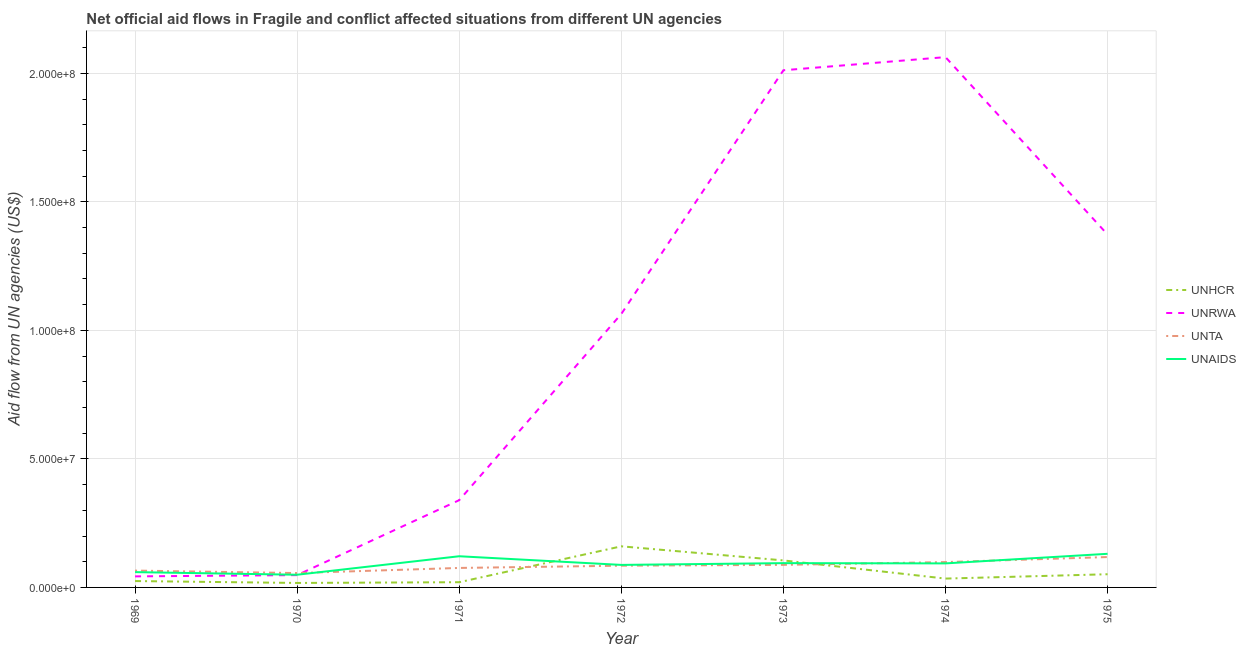Is the number of lines equal to the number of legend labels?
Ensure brevity in your answer.  Yes. What is the amount of aid given by unaids in 1973?
Provide a succinct answer. 9.45e+06. Across all years, what is the maximum amount of aid given by unta?
Ensure brevity in your answer.  1.18e+07. Across all years, what is the minimum amount of aid given by unaids?
Offer a terse response. 4.94e+06. In which year was the amount of aid given by unrwa maximum?
Offer a terse response. 1974. What is the total amount of aid given by unrwa in the graph?
Offer a very short reply. 6.94e+08. What is the difference between the amount of aid given by unta in 1969 and that in 1971?
Give a very brief answer. -1.03e+06. What is the difference between the amount of aid given by unhcr in 1972 and the amount of aid given by unrwa in 1970?
Offer a terse response. 1.12e+07. What is the average amount of aid given by unhcr per year?
Your response must be concise. 5.90e+06. In the year 1973, what is the difference between the amount of aid given by unrwa and amount of aid given by unta?
Your answer should be very brief. 1.92e+08. In how many years, is the amount of aid given by unrwa greater than 60000000 US$?
Offer a terse response. 4. What is the ratio of the amount of aid given by unta in 1970 to that in 1971?
Your response must be concise. 0.74. Is the amount of aid given by unrwa in 1969 less than that in 1970?
Give a very brief answer. Yes. Is the difference between the amount of aid given by unhcr in 1972 and 1975 greater than the difference between the amount of aid given by unta in 1972 and 1975?
Make the answer very short. Yes. What is the difference between the highest and the second highest amount of aid given by unaids?
Your answer should be very brief. 9.50e+05. What is the difference between the highest and the lowest amount of aid given by unhcr?
Your answer should be very brief. 1.42e+07. In how many years, is the amount of aid given by unta greater than the average amount of aid given by unta taken over all years?
Provide a succinct answer. 4. Is the sum of the amount of aid given by unrwa in 1971 and 1972 greater than the maximum amount of aid given by unaids across all years?
Offer a very short reply. Yes. Is the amount of aid given by unhcr strictly less than the amount of aid given by unrwa over the years?
Provide a short and direct response. Yes. How many lines are there?
Provide a short and direct response. 4. What is the difference between two consecutive major ticks on the Y-axis?
Your response must be concise. 5.00e+07. Does the graph contain any zero values?
Provide a short and direct response. No. What is the title of the graph?
Provide a succinct answer. Net official aid flows in Fragile and conflict affected situations from different UN agencies. What is the label or title of the X-axis?
Ensure brevity in your answer.  Year. What is the label or title of the Y-axis?
Provide a short and direct response. Aid flow from UN agencies (US$). What is the Aid flow from UN agencies (US$) in UNHCR in 1969?
Offer a terse response. 2.48e+06. What is the Aid flow from UN agencies (US$) of UNRWA in 1969?
Your response must be concise. 4.30e+06. What is the Aid flow from UN agencies (US$) in UNTA in 1969?
Provide a succinct answer. 6.55e+06. What is the Aid flow from UN agencies (US$) in UNAIDS in 1969?
Your answer should be very brief. 5.95e+06. What is the Aid flow from UN agencies (US$) of UNHCR in 1970?
Provide a short and direct response. 1.74e+06. What is the Aid flow from UN agencies (US$) in UNRWA in 1970?
Your answer should be very brief. 4.79e+06. What is the Aid flow from UN agencies (US$) of UNTA in 1970?
Offer a very short reply. 5.59e+06. What is the Aid flow from UN agencies (US$) of UNAIDS in 1970?
Offer a very short reply. 4.94e+06. What is the Aid flow from UN agencies (US$) in UNHCR in 1971?
Make the answer very short. 2.03e+06. What is the Aid flow from UN agencies (US$) in UNRWA in 1971?
Your answer should be very brief. 3.40e+07. What is the Aid flow from UN agencies (US$) of UNTA in 1971?
Give a very brief answer. 7.58e+06. What is the Aid flow from UN agencies (US$) of UNAIDS in 1971?
Keep it short and to the point. 1.21e+07. What is the Aid flow from UN agencies (US$) in UNHCR in 1972?
Provide a succinct answer. 1.60e+07. What is the Aid flow from UN agencies (US$) of UNRWA in 1972?
Offer a very short reply. 1.06e+08. What is the Aid flow from UN agencies (US$) of UNTA in 1972?
Ensure brevity in your answer.  8.46e+06. What is the Aid flow from UN agencies (US$) in UNAIDS in 1972?
Provide a short and direct response. 8.76e+06. What is the Aid flow from UN agencies (US$) of UNHCR in 1973?
Keep it short and to the point. 1.05e+07. What is the Aid flow from UN agencies (US$) of UNRWA in 1973?
Make the answer very short. 2.01e+08. What is the Aid flow from UN agencies (US$) in UNTA in 1973?
Your answer should be very brief. 8.78e+06. What is the Aid flow from UN agencies (US$) of UNAIDS in 1973?
Your answer should be compact. 9.45e+06. What is the Aid flow from UN agencies (US$) of UNHCR in 1974?
Your answer should be compact. 3.44e+06. What is the Aid flow from UN agencies (US$) of UNRWA in 1974?
Give a very brief answer. 2.06e+08. What is the Aid flow from UN agencies (US$) in UNTA in 1974?
Keep it short and to the point. 9.86e+06. What is the Aid flow from UN agencies (US$) of UNAIDS in 1974?
Provide a short and direct response. 9.35e+06. What is the Aid flow from UN agencies (US$) of UNHCR in 1975?
Provide a succinct answer. 5.13e+06. What is the Aid flow from UN agencies (US$) of UNRWA in 1975?
Offer a terse response. 1.37e+08. What is the Aid flow from UN agencies (US$) in UNTA in 1975?
Offer a terse response. 1.18e+07. What is the Aid flow from UN agencies (US$) of UNAIDS in 1975?
Offer a terse response. 1.31e+07. Across all years, what is the maximum Aid flow from UN agencies (US$) in UNHCR?
Provide a succinct answer. 1.60e+07. Across all years, what is the maximum Aid flow from UN agencies (US$) in UNRWA?
Ensure brevity in your answer.  2.06e+08. Across all years, what is the maximum Aid flow from UN agencies (US$) in UNTA?
Offer a very short reply. 1.18e+07. Across all years, what is the maximum Aid flow from UN agencies (US$) in UNAIDS?
Your response must be concise. 1.31e+07. Across all years, what is the minimum Aid flow from UN agencies (US$) in UNHCR?
Your answer should be compact. 1.74e+06. Across all years, what is the minimum Aid flow from UN agencies (US$) of UNRWA?
Offer a very short reply. 4.30e+06. Across all years, what is the minimum Aid flow from UN agencies (US$) in UNTA?
Your answer should be compact. 5.59e+06. Across all years, what is the minimum Aid flow from UN agencies (US$) of UNAIDS?
Your answer should be very brief. 4.94e+06. What is the total Aid flow from UN agencies (US$) of UNHCR in the graph?
Your answer should be compact. 4.13e+07. What is the total Aid flow from UN agencies (US$) in UNRWA in the graph?
Ensure brevity in your answer.  6.94e+08. What is the total Aid flow from UN agencies (US$) of UNTA in the graph?
Your response must be concise. 5.86e+07. What is the total Aid flow from UN agencies (US$) in UNAIDS in the graph?
Your response must be concise. 6.37e+07. What is the difference between the Aid flow from UN agencies (US$) in UNHCR in 1969 and that in 1970?
Offer a terse response. 7.40e+05. What is the difference between the Aid flow from UN agencies (US$) in UNRWA in 1969 and that in 1970?
Offer a very short reply. -4.90e+05. What is the difference between the Aid flow from UN agencies (US$) in UNTA in 1969 and that in 1970?
Provide a succinct answer. 9.60e+05. What is the difference between the Aid flow from UN agencies (US$) of UNAIDS in 1969 and that in 1970?
Ensure brevity in your answer.  1.01e+06. What is the difference between the Aid flow from UN agencies (US$) in UNHCR in 1969 and that in 1971?
Your response must be concise. 4.50e+05. What is the difference between the Aid flow from UN agencies (US$) of UNRWA in 1969 and that in 1971?
Provide a succinct answer. -2.96e+07. What is the difference between the Aid flow from UN agencies (US$) in UNTA in 1969 and that in 1971?
Make the answer very short. -1.03e+06. What is the difference between the Aid flow from UN agencies (US$) in UNAIDS in 1969 and that in 1971?
Provide a short and direct response. -6.18e+06. What is the difference between the Aid flow from UN agencies (US$) in UNHCR in 1969 and that in 1972?
Your answer should be compact. -1.35e+07. What is the difference between the Aid flow from UN agencies (US$) of UNRWA in 1969 and that in 1972?
Your response must be concise. -1.02e+08. What is the difference between the Aid flow from UN agencies (US$) in UNTA in 1969 and that in 1972?
Make the answer very short. -1.91e+06. What is the difference between the Aid flow from UN agencies (US$) in UNAIDS in 1969 and that in 1972?
Make the answer very short. -2.81e+06. What is the difference between the Aid flow from UN agencies (US$) of UNHCR in 1969 and that in 1973?
Keep it short and to the point. -8.03e+06. What is the difference between the Aid flow from UN agencies (US$) in UNRWA in 1969 and that in 1973?
Ensure brevity in your answer.  -1.97e+08. What is the difference between the Aid flow from UN agencies (US$) in UNTA in 1969 and that in 1973?
Your answer should be very brief. -2.23e+06. What is the difference between the Aid flow from UN agencies (US$) of UNAIDS in 1969 and that in 1973?
Offer a very short reply. -3.50e+06. What is the difference between the Aid flow from UN agencies (US$) of UNHCR in 1969 and that in 1974?
Your answer should be compact. -9.60e+05. What is the difference between the Aid flow from UN agencies (US$) in UNRWA in 1969 and that in 1974?
Provide a short and direct response. -2.02e+08. What is the difference between the Aid flow from UN agencies (US$) of UNTA in 1969 and that in 1974?
Your response must be concise. -3.31e+06. What is the difference between the Aid flow from UN agencies (US$) in UNAIDS in 1969 and that in 1974?
Your answer should be compact. -3.40e+06. What is the difference between the Aid flow from UN agencies (US$) of UNHCR in 1969 and that in 1975?
Your response must be concise. -2.65e+06. What is the difference between the Aid flow from UN agencies (US$) of UNRWA in 1969 and that in 1975?
Ensure brevity in your answer.  -1.33e+08. What is the difference between the Aid flow from UN agencies (US$) in UNTA in 1969 and that in 1975?
Provide a short and direct response. -5.27e+06. What is the difference between the Aid flow from UN agencies (US$) in UNAIDS in 1969 and that in 1975?
Give a very brief answer. -7.13e+06. What is the difference between the Aid flow from UN agencies (US$) of UNRWA in 1970 and that in 1971?
Your answer should be compact. -2.92e+07. What is the difference between the Aid flow from UN agencies (US$) in UNTA in 1970 and that in 1971?
Provide a short and direct response. -1.99e+06. What is the difference between the Aid flow from UN agencies (US$) of UNAIDS in 1970 and that in 1971?
Your answer should be very brief. -7.19e+06. What is the difference between the Aid flow from UN agencies (US$) in UNHCR in 1970 and that in 1972?
Make the answer very short. -1.42e+07. What is the difference between the Aid flow from UN agencies (US$) in UNRWA in 1970 and that in 1972?
Your response must be concise. -1.02e+08. What is the difference between the Aid flow from UN agencies (US$) in UNTA in 1970 and that in 1972?
Provide a short and direct response. -2.87e+06. What is the difference between the Aid flow from UN agencies (US$) of UNAIDS in 1970 and that in 1972?
Provide a short and direct response. -3.82e+06. What is the difference between the Aid flow from UN agencies (US$) in UNHCR in 1970 and that in 1973?
Provide a succinct answer. -8.77e+06. What is the difference between the Aid flow from UN agencies (US$) of UNRWA in 1970 and that in 1973?
Your response must be concise. -1.96e+08. What is the difference between the Aid flow from UN agencies (US$) of UNTA in 1970 and that in 1973?
Your answer should be very brief. -3.19e+06. What is the difference between the Aid flow from UN agencies (US$) in UNAIDS in 1970 and that in 1973?
Provide a short and direct response. -4.51e+06. What is the difference between the Aid flow from UN agencies (US$) of UNHCR in 1970 and that in 1974?
Provide a succinct answer. -1.70e+06. What is the difference between the Aid flow from UN agencies (US$) of UNRWA in 1970 and that in 1974?
Your answer should be compact. -2.02e+08. What is the difference between the Aid flow from UN agencies (US$) of UNTA in 1970 and that in 1974?
Your answer should be very brief. -4.27e+06. What is the difference between the Aid flow from UN agencies (US$) in UNAIDS in 1970 and that in 1974?
Ensure brevity in your answer.  -4.41e+06. What is the difference between the Aid flow from UN agencies (US$) of UNHCR in 1970 and that in 1975?
Keep it short and to the point. -3.39e+06. What is the difference between the Aid flow from UN agencies (US$) in UNRWA in 1970 and that in 1975?
Your answer should be very brief. -1.32e+08. What is the difference between the Aid flow from UN agencies (US$) in UNTA in 1970 and that in 1975?
Your response must be concise. -6.23e+06. What is the difference between the Aid flow from UN agencies (US$) of UNAIDS in 1970 and that in 1975?
Provide a short and direct response. -8.14e+06. What is the difference between the Aid flow from UN agencies (US$) in UNHCR in 1971 and that in 1972?
Provide a succinct answer. -1.40e+07. What is the difference between the Aid flow from UN agencies (US$) in UNRWA in 1971 and that in 1972?
Your answer should be compact. -7.24e+07. What is the difference between the Aid flow from UN agencies (US$) of UNTA in 1971 and that in 1972?
Ensure brevity in your answer.  -8.80e+05. What is the difference between the Aid flow from UN agencies (US$) of UNAIDS in 1971 and that in 1972?
Provide a succinct answer. 3.37e+06. What is the difference between the Aid flow from UN agencies (US$) in UNHCR in 1971 and that in 1973?
Make the answer very short. -8.48e+06. What is the difference between the Aid flow from UN agencies (US$) of UNRWA in 1971 and that in 1973?
Offer a very short reply. -1.67e+08. What is the difference between the Aid flow from UN agencies (US$) of UNTA in 1971 and that in 1973?
Keep it short and to the point. -1.20e+06. What is the difference between the Aid flow from UN agencies (US$) in UNAIDS in 1971 and that in 1973?
Offer a very short reply. 2.68e+06. What is the difference between the Aid flow from UN agencies (US$) in UNHCR in 1971 and that in 1974?
Your answer should be compact. -1.41e+06. What is the difference between the Aid flow from UN agencies (US$) in UNRWA in 1971 and that in 1974?
Make the answer very short. -1.72e+08. What is the difference between the Aid flow from UN agencies (US$) of UNTA in 1971 and that in 1974?
Give a very brief answer. -2.28e+06. What is the difference between the Aid flow from UN agencies (US$) in UNAIDS in 1971 and that in 1974?
Keep it short and to the point. 2.78e+06. What is the difference between the Aid flow from UN agencies (US$) in UNHCR in 1971 and that in 1975?
Offer a very short reply. -3.10e+06. What is the difference between the Aid flow from UN agencies (US$) in UNRWA in 1971 and that in 1975?
Provide a short and direct response. -1.03e+08. What is the difference between the Aid flow from UN agencies (US$) in UNTA in 1971 and that in 1975?
Provide a short and direct response. -4.24e+06. What is the difference between the Aid flow from UN agencies (US$) of UNAIDS in 1971 and that in 1975?
Provide a succinct answer. -9.50e+05. What is the difference between the Aid flow from UN agencies (US$) in UNHCR in 1972 and that in 1973?
Offer a terse response. 5.48e+06. What is the difference between the Aid flow from UN agencies (US$) of UNRWA in 1972 and that in 1973?
Ensure brevity in your answer.  -9.48e+07. What is the difference between the Aid flow from UN agencies (US$) of UNTA in 1972 and that in 1973?
Keep it short and to the point. -3.20e+05. What is the difference between the Aid flow from UN agencies (US$) in UNAIDS in 1972 and that in 1973?
Your answer should be compact. -6.90e+05. What is the difference between the Aid flow from UN agencies (US$) of UNHCR in 1972 and that in 1974?
Provide a short and direct response. 1.26e+07. What is the difference between the Aid flow from UN agencies (US$) in UNRWA in 1972 and that in 1974?
Keep it short and to the point. -9.99e+07. What is the difference between the Aid flow from UN agencies (US$) of UNTA in 1972 and that in 1974?
Offer a very short reply. -1.40e+06. What is the difference between the Aid flow from UN agencies (US$) of UNAIDS in 1972 and that in 1974?
Your response must be concise. -5.90e+05. What is the difference between the Aid flow from UN agencies (US$) of UNHCR in 1972 and that in 1975?
Offer a terse response. 1.09e+07. What is the difference between the Aid flow from UN agencies (US$) of UNRWA in 1972 and that in 1975?
Provide a short and direct response. -3.09e+07. What is the difference between the Aid flow from UN agencies (US$) of UNTA in 1972 and that in 1975?
Provide a succinct answer. -3.36e+06. What is the difference between the Aid flow from UN agencies (US$) in UNAIDS in 1972 and that in 1975?
Ensure brevity in your answer.  -4.32e+06. What is the difference between the Aid flow from UN agencies (US$) of UNHCR in 1973 and that in 1974?
Offer a very short reply. 7.07e+06. What is the difference between the Aid flow from UN agencies (US$) in UNRWA in 1973 and that in 1974?
Keep it short and to the point. -5.11e+06. What is the difference between the Aid flow from UN agencies (US$) of UNTA in 1973 and that in 1974?
Keep it short and to the point. -1.08e+06. What is the difference between the Aid flow from UN agencies (US$) of UNAIDS in 1973 and that in 1974?
Offer a very short reply. 1.00e+05. What is the difference between the Aid flow from UN agencies (US$) in UNHCR in 1973 and that in 1975?
Make the answer very short. 5.38e+06. What is the difference between the Aid flow from UN agencies (US$) of UNRWA in 1973 and that in 1975?
Ensure brevity in your answer.  6.39e+07. What is the difference between the Aid flow from UN agencies (US$) of UNTA in 1973 and that in 1975?
Offer a very short reply. -3.04e+06. What is the difference between the Aid flow from UN agencies (US$) in UNAIDS in 1973 and that in 1975?
Keep it short and to the point. -3.63e+06. What is the difference between the Aid flow from UN agencies (US$) in UNHCR in 1974 and that in 1975?
Offer a terse response. -1.69e+06. What is the difference between the Aid flow from UN agencies (US$) in UNRWA in 1974 and that in 1975?
Offer a very short reply. 6.90e+07. What is the difference between the Aid flow from UN agencies (US$) of UNTA in 1974 and that in 1975?
Keep it short and to the point. -1.96e+06. What is the difference between the Aid flow from UN agencies (US$) in UNAIDS in 1974 and that in 1975?
Provide a short and direct response. -3.73e+06. What is the difference between the Aid flow from UN agencies (US$) in UNHCR in 1969 and the Aid flow from UN agencies (US$) in UNRWA in 1970?
Give a very brief answer. -2.31e+06. What is the difference between the Aid flow from UN agencies (US$) in UNHCR in 1969 and the Aid flow from UN agencies (US$) in UNTA in 1970?
Offer a terse response. -3.11e+06. What is the difference between the Aid flow from UN agencies (US$) of UNHCR in 1969 and the Aid flow from UN agencies (US$) of UNAIDS in 1970?
Ensure brevity in your answer.  -2.46e+06. What is the difference between the Aid flow from UN agencies (US$) in UNRWA in 1969 and the Aid flow from UN agencies (US$) in UNTA in 1970?
Offer a very short reply. -1.29e+06. What is the difference between the Aid flow from UN agencies (US$) of UNRWA in 1969 and the Aid flow from UN agencies (US$) of UNAIDS in 1970?
Make the answer very short. -6.40e+05. What is the difference between the Aid flow from UN agencies (US$) in UNTA in 1969 and the Aid flow from UN agencies (US$) in UNAIDS in 1970?
Make the answer very short. 1.61e+06. What is the difference between the Aid flow from UN agencies (US$) of UNHCR in 1969 and the Aid flow from UN agencies (US$) of UNRWA in 1971?
Provide a succinct answer. -3.15e+07. What is the difference between the Aid flow from UN agencies (US$) of UNHCR in 1969 and the Aid flow from UN agencies (US$) of UNTA in 1971?
Your response must be concise. -5.10e+06. What is the difference between the Aid flow from UN agencies (US$) of UNHCR in 1969 and the Aid flow from UN agencies (US$) of UNAIDS in 1971?
Your answer should be compact. -9.65e+06. What is the difference between the Aid flow from UN agencies (US$) in UNRWA in 1969 and the Aid flow from UN agencies (US$) in UNTA in 1971?
Make the answer very short. -3.28e+06. What is the difference between the Aid flow from UN agencies (US$) in UNRWA in 1969 and the Aid flow from UN agencies (US$) in UNAIDS in 1971?
Your answer should be compact. -7.83e+06. What is the difference between the Aid flow from UN agencies (US$) of UNTA in 1969 and the Aid flow from UN agencies (US$) of UNAIDS in 1971?
Provide a succinct answer. -5.58e+06. What is the difference between the Aid flow from UN agencies (US$) in UNHCR in 1969 and the Aid flow from UN agencies (US$) in UNRWA in 1972?
Offer a very short reply. -1.04e+08. What is the difference between the Aid flow from UN agencies (US$) of UNHCR in 1969 and the Aid flow from UN agencies (US$) of UNTA in 1972?
Ensure brevity in your answer.  -5.98e+06. What is the difference between the Aid flow from UN agencies (US$) in UNHCR in 1969 and the Aid flow from UN agencies (US$) in UNAIDS in 1972?
Offer a very short reply. -6.28e+06. What is the difference between the Aid flow from UN agencies (US$) in UNRWA in 1969 and the Aid flow from UN agencies (US$) in UNTA in 1972?
Your answer should be very brief. -4.16e+06. What is the difference between the Aid flow from UN agencies (US$) of UNRWA in 1969 and the Aid flow from UN agencies (US$) of UNAIDS in 1972?
Your answer should be compact. -4.46e+06. What is the difference between the Aid flow from UN agencies (US$) in UNTA in 1969 and the Aid flow from UN agencies (US$) in UNAIDS in 1972?
Provide a short and direct response. -2.21e+06. What is the difference between the Aid flow from UN agencies (US$) of UNHCR in 1969 and the Aid flow from UN agencies (US$) of UNRWA in 1973?
Offer a terse response. -1.99e+08. What is the difference between the Aid flow from UN agencies (US$) of UNHCR in 1969 and the Aid flow from UN agencies (US$) of UNTA in 1973?
Offer a very short reply. -6.30e+06. What is the difference between the Aid flow from UN agencies (US$) in UNHCR in 1969 and the Aid flow from UN agencies (US$) in UNAIDS in 1973?
Provide a short and direct response. -6.97e+06. What is the difference between the Aid flow from UN agencies (US$) in UNRWA in 1969 and the Aid flow from UN agencies (US$) in UNTA in 1973?
Provide a succinct answer. -4.48e+06. What is the difference between the Aid flow from UN agencies (US$) of UNRWA in 1969 and the Aid flow from UN agencies (US$) of UNAIDS in 1973?
Provide a succinct answer. -5.15e+06. What is the difference between the Aid flow from UN agencies (US$) in UNTA in 1969 and the Aid flow from UN agencies (US$) in UNAIDS in 1973?
Offer a very short reply. -2.90e+06. What is the difference between the Aid flow from UN agencies (US$) of UNHCR in 1969 and the Aid flow from UN agencies (US$) of UNRWA in 1974?
Give a very brief answer. -2.04e+08. What is the difference between the Aid flow from UN agencies (US$) of UNHCR in 1969 and the Aid flow from UN agencies (US$) of UNTA in 1974?
Make the answer very short. -7.38e+06. What is the difference between the Aid flow from UN agencies (US$) in UNHCR in 1969 and the Aid flow from UN agencies (US$) in UNAIDS in 1974?
Make the answer very short. -6.87e+06. What is the difference between the Aid flow from UN agencies (US$) in UNRWA in 1969 and the Aid flow from UN agencies (US$) in UNTA in 1974?
Offer a very short reply. -5.56e+06. What is the difference between the Aid flow from UN agencies (US$) of UNRWA in 1969 and the Aid flow from UN agencies (US$) of UNAIDS in 1974?
Your response must be concise. -5.05e+06. What is the difference between the Aid flow from UN agencies (US$) in UNTA in 1969 and the Aid flow from UN agencies (US$) in UNAIDS in 1974?
Your response must be concise. -2.80e+06. What is the difference between the Aid flow from UN agencies (US$) of UNHCR in 1969 and the Aid flow from UN agencies (US$) of UNRWA in 1975?
Offer a terse response. -1.35e+08. What is the difference between the Aid flow from UN agencies (US$) in UNHCR in 1969 and the Aid flow from UN agencies (US$) in UNTA in 1975?
Offer a very short reply. -9.34e+06. What is the difference between the Aid flow from UN agencies (US$) of UNHCR in 1969 and the Aid flow from UN agencies (US$) of UNAIDS in 1975?
Your response must be concise. -1.06e+07. What is the difference between the Aid flow from UN agencies (US$) in UNRWA in 1969 and the Aid flow from UN agencies (US$) in UNTA in 1975?
Keep it short and to the point. -7.52e+06. What is the difference between the Aid flow from UN agencies (US$) in UNRWA in 1969 and the Aid flow from UN agencies (US$) in UNAIDS in 1975?
Your answer should be very brief. -8.78e+06. What is the difference between the Aid flow from UN agencies (US$) of UNTA in 1969 and the Aid flow from UN agencies (US$) of UNAIDS in 1975?
Your answer should be very brief. -6.53e+06. What is the difference between the Aid flow from UN agencies (US$) of UNHCR in 1970 and the Aid flow from UN agencies (US$) of UNRWA in 1971?
Offer a terse response. -3.22e+07. What is the difference between the Aid flow from UN agencies (US$) of UNHCR in 1970 and the Aid flow from UN agencies (US$) of UNTA in 1971?
Provide a succinct answer. -5.84e+06. What is the difference between the Aid flow from UN agencies (US$) in UNHCR in 1970 and the Aid flow from UN agencies (US$) in UNAIDS in 1971?
Make the answer very short. -1.04e+07. What is the difference between the Aid flow from UN agencies (US$) in UNRWA in 1970 and the Aid flow from UN agencies (US$) in UNTA in 1971?
Provide a succinct answer. -2.79e+06. What is the difference between the Aid flow from UN agencies (US$) of UNRWA in 1970 and the Aid flow from UN agencies (US$) of UNAIDS in 1971?
Give a very brief answer. -7.34e+06. What is the difference between the Aid flow from UN agencies (US$) of UNTA in 1970 and the Aid flow from UN agencies (US$) of UNAIDS in 1971?
Make the answer very short. -6.54e+06. What is the difference between the Aid flow from UN agencies (US$) of UNHCR in 1970 and the Aid flow from UN agencies (US$) of UNRWA in 1972?
Offer a very short reply. -1.05e+08. What is the difference between the Aid flow from UN agencies (US$) of UNHCR in 1970 and the Aid flow from UN agencies (US$) of UNTA in 1972?
Provide a short and direct response. -6.72e+06. What is the difference between the Aid flow from UN agencies (US$) of UNHCR in 1970 and the Aid flow from UN agencies (US$) of UNAIDS in 1972?
Keep it short and to the point. -7.02e+06. What is the difference between the Aid flow from UN agencies (US$) of UNRWA in 1970 and the Aid flow from UN agencies (US$) of UNTA in 1972?
Provide a succinct answer. -3.67e+06. What is the difference between the Aid flow from UN agencies (US$) in UNRWA in 1970 and the Aid flow from UN agencies (US$) in UNAIDS in 1972?
Provide a succinct answer. -3.97e+06. What is the difference between the Aid flow from UN agencies (US$) in UNTA in 1970 and the Aid flow from UN agencies (US$) in UNAIDS in 1972?
Keep it short and to the point. -3.17e+06. What is the difference between the Aid flow from UN agencies (US$) in UNHCR in 1970 and the Aid flow from UN agencies (US$) in UNRWA in 1973?
Make the answer very short. -1.99e+08. What is the difference between the Aid flow from UN agencies (US$) in UNHCR in 1970 and the Aid flow from UN agencies (US$) in UNTA in 1973?
Offer a terse response. -7.04e+06. What is the difference between the Aid flow from UN agencies (US$) of UNHCR in 1970 and the Aid flow from UN agencies (US$) of UNAIDS in 1973?
Provide a short and direct response. -7.71e+06. What is the difference between the Aid flow from UN agencies (US$) in UNRWA in 1970 and the Aid flow from UN agencies (US$) in UNTA in 1973?
Provide a succinct answer. -3.99e+06. What is the difference between the Aid flow from UN agencies (US$) in UNRWA in 1970 and the Aid flow from UN agencies (US$) in UNAIDS in 1973?
Your response must be concise. -4.66e+06. What is the difference between the Aid flow from UN agencies (US$) in UNTA in 1970 and the Aid flow from UN agencies (US$) in UNAIDS in 1973?
Ensure brevity in your answer.  -3.86e+06. What is the difference between the Aid flow from UN agencies (US$) of UNHCR in 1970 and the Aid flow from UN agencies (US$) of UNRWA in 1974?
Your answer should be compact. -2.05e+08. What is the difference between the Aid flow from UN agencies (US$) of UNHCR in 1970 and the Aid flow from UN agencies (US$) of UNTA in 1974?
Provide a short and direct response. -8.12e+06. What is the difference between the Aid flow from UN agencies (US$) in UNHCR in 1970 and the Aid flow from UN agencies (US$) in UNAIDS in 1974?
Your answer should be compact. -7.61e+06. What is the difference between the Aid flow from UN agencies (US$) in UNRWA in 1970 and the Aid flow from UN agencies (US$) in UNTA in 1974?
Provide a succinct answer. -5.07e+06. What is the difference between the Aid flow from UN agencies (US$) of UNRWA in 1970 and the Aid flow from UN agencies (US$) of UNAIDS in 1974?
Give a very brief answer. -4.56e+06. What is the difference between the Aid flow from UN agencies (US$) of UNTA in 1970 and the Aid flow from UN agencies (US$) of UNAIDS in 1974?
Keep it short and to the point. -3.76e+06. What is the difference between the Aid flow from UN agencies (US$) of UNHCR in 1970 and the Aid flow from UN agencies (US$) of UNRWA in 1975?
Provide a short and direct response. -1.36e+08. What is the difference between the Aid flow from UN agencies (US$) in UNHCR in 1970 and the Aid flow from UN agencies (US$) in UNTA in 1975?
Your answer should be very brief. -1.01e+07. What is the difference between the Aid flow from UN agencies (US$) of UNHCR in 1970 and the Aid flow from UN agencies (US$) of UNAIDS in 1975?
Make the answer very short. -1.13e+07. What is the difference between the Aid flow from UN agencies (US$) of UNRWA in 1970 and the Aid flow from UN agencies (US$) of UNTA in 1975?
Keep it short and to the point. -7.03e+06. What is the difference between the Aid flow from UN agencies (US$) in UNRWA in 1970 and the Aid flow from UN agencies (US$) in UNAIDS in 1975?
Offer a very short reply. -8.29e+06. What is the difference between the Aid flow from UN agencies (US$) of UNTA in 1970 and the Aid flow from UN agencies (US$) of UNAIDS in 1975?
Give a very brief answer. -7.49e+06. What is the difference between the Aid flow from UN agencies (US$) in UNHCR in 1971 and the Aid flow from UN agencies (US$) in UNRWA in 1972?
Ensure brevity in your answer.  -1.04e+08. What is the difference between the Aid flow from UN agencies (US$) of UNHCR in 1971 and the Aid flow from UN agencies (US$) of UNTA in 1972?
Provide a succinct answer. -6.43e+06. What is the difference between the Aid flow from UN agencies (US$) in UNHCR in 1971 and the Aid flow from UN agencies (US$) in UNAIDS in 1972?
Give a very brief answer. -6.73e+06. What is the difference between the Aid flow from UN agencies (US$) of UNRWA in 1971 and the Aid flow from UN agencies (US$) of UNTA in 1972?
Make the answer very short. 2.55e+07. What is the difference between the Aid flow from UN agencies (US$) of UNRWA in 1971 and the Aid flow from UN agencies (US$) of UNAIDS in 1972?
Your answer should be very brief. 2.52e+07. What is the difference between the Aid flow from UN agencies (US$) in UNTA in 1971 and the Aid flow from UN agencies (US$) in UNAIDS in 1972?
Offer a terse response. -1.18e+06. What is the difference between the Aid flow from UN agencies (US$) of UNHCR in 1971 and the Aid flow from UN agencies (US$) of UNRWA in 1973?
Your answer should be compact. -1.99e+08. What is the difference between the Aid flow from UN agencies (US$) of UNHCR in 1971 and the Aid flow from UN agencies (US$) of UNTA in 1973?
Your answer should be very brief. -6.75e+06. What is the difference between the Aid flow from UN agencies (US$) in UNHCR in 1971 and the Aid flow from UN agencies (US$) in UNAIDS in 1973?
Make the answer very short. -7.42e+06. What is the difference between the Aid flow from UN agencies (US$) in UNRWA in 1971 and the Aid flow from UN agencies (US$) in UNTA in 1973?
Keep it short and to the point. 2.52e+07. What is the difference between the Aid flow from UN agencies (US$) of UNRWA in 1971 and the Aid flow from UN agencies (US$) of UNAIDS in 1973?
Your answer should be compact. 2.45e+07. What is the difference between the Aid flow from UN agencies (US$) in UNTA in 1971 and the Aid flow from UN agencies (US$) in UNAIDS in 1973?
Your answer should be compact. -1.87e+06. What is the difference between the Aid flow from UN agencies (US$) of UNHCR in 1971 and the Aid flow from UN agencies (US$) of UNRWA in 1974?
Provide a succinct answer. -2.04e+08. What is the difference between the Aid flow from UN agencies (US$) of UNHCR in 1971 and the Aid flow from UN agencies (US$) of UNTA in 1974?
Your response must be concise. -7.83e+06. What is the difference between the Aid flow from UN agencies (US$) of UNHCR in 1971 and the Aid flow from UN agencies (US$) of UNAIDS in 1974?
Provide a succinct answer. -7.32e+06. What is the difference between the Aid flow from UN agencies (US$) of UNRWA in 1971 and the Aid flow from UN agencies (US$) of UNTA in 1974?
Your answer should be very brief. 2.41e+07. What is the difference between the Aid flow from UN agencies (US$) in UNRWA in 1971 and the Aid flow from UN agencies (US$) in UNAIDS in 1974?
Ensure brevity in your answer.  2.46e+07. What is the difference between the Aid flow from UN agencies (US$) of UNTA in 1971 and the Aid flow from UN agencies (US$) of UNAIDS in 1974?
Your answer should be compact. -1.77e+06. What is the difference between the Aid flow from UN agencies (US$) of UNHCR in 1971 and the Aid flow from UN agencies (US$) of UNRWA in 1975?
Ensure brevity in your answer.  -1.35e+08. What is the difference between the Aid flow from UN agencies (US$) in UNHCR in 1971 and the Aid flow from UN agencies (US$) in UNTA in 1975?
Keep it short and to the point. -9.79e+06. What is the difference between the Aid flow from UN agencies (US$) in UNHCR in 1971 and the Aid flow from UN agencies (US$) in UNAIDS in 1975?
Offer a very short reply. -1.10e+07. What is the difference between the Aid flow from UN agencies (US$) in UNRWA in 1971 and the Aid flow from UN agencies (US$) in UNTA in 1975?
Offer a very short reply. 2.21e+07. What is the difference between the Aid flow from UN agencies (US$) of UNRWA in 1971 and the Aid flow from UN agencies (US$) of UNAIDS in 1975?
Your answer should be compact. 2.09e+07. What is the difference between the Aid flow from UN agencies (US$) of UNTA in 1971 and the Aid flow from UN agencies (US$) of UNAIDS in 1975?
Ensure brevity in your answer.  -5.50e+06. What is the difference between the Aid flow from UN agencies (US$) of UNHCR in 1972 and the Aid flow from UN agencies (US$) of UNRWA in 1973?
Keep it short and to the point. -1.85e+08. What is the difference between the Aid flow from UN agencies (US$) in UNHCR in 1972 and the Aid flow from UN agencies (US$) in UNTA in 1973?
Your answer should be very brief. 7.21e+06. What is the difference between the Aid flow from UN agencies (US$) in UNHCR in 1972 and the Aid flow from UN agencies (US$) in UNAIDS in 1973?
Give a very brief answer. 6.54e+06. What is the difference between the Aid flow from UN agencies (US$) in UNRWA in 1972 and the Aid flow from UN agencies (US$) in UNTA in 1973?
Your answer should be compact. 9.76e+07. What is the difference between the Aid flow from UN agencies (US$) of UNRWA in 1972 and the Aid flow from UN agencies (US$) of UNAIDS in 1973?
Offer a very short reply. 9.70e+07. What is the difference between the Aid flow from UN agencies (US$) in UNTA in 1972 and the Aid flow from UN agencies (US$) in UNAIDS in 1973?
Your answer should be very brief. -9.90e+05. What is the difference between the Aid flow from UN agencies (US$) of UNHCR in 1972 and the Aid flow from UN agencies (US$) of UNRWA in 1974?
Give a very brief answer. -1.90e+08. What is the difference between the Aid flow from UN agencies (US$) in UNHCR in 1972 and the Aid flow from UN agencies (US$) in UNTA in 1974?
Ensure brevity in your answer.  6.13e+06. What is the difference between the Aid flow from UN agencies (US$) of UNHCR in 1972 and the Aid flow from UN agencies (US$) of UNAIDS in 1974?
Keep it short and to the point. 6.64e+06. What is the difference between the Aid flow from UN agencies (US$) of UNRWA in 1972 and the Aid flow from UN agencies (US$) of UNTA in 1974?
Your response must be concise. 9.65e+07. What is the difference between the Aid flow from UN agencies (US$) in UNRWA in 1972 and the Aid flow from UN agencies (US$) in UNAIDS in 1974?
Provide a succinct answer. 9.70e+07. What is the difference between the Aid flow from UN agencies (US$) of UNTA in 1972 and the Aid flow from UN agencies (US$) of UNAIDS in 1974?
Your response must be concise. -8.90e+05. What is the difference between the Aid flow from UN agencies (US$) in UNHCR in 1972 and the Aid flow from UN agencies (US$) in UNRWA in 1975?
Provide a short and direct response. -1.21e+08. What is the difference between the Aid flow from UN agencies (US$) of UNHCR in 1972 and the Aid flow from UN agencies (US$) of UNTA in 1975?
Provide a short and direct response. 4.17e+06. What is the difference between the Aid flow from UN agencies (US$) of UNHCR in 1972 and the Aid flow from UN agencies (US$) of UNAIDS in 1975?
Offer a terse response. 2.91e+06. What is the difference between the Aid flow from UN agencies (US$) in UNRWA in 1972 and the Aid flow from UN agencies (US$) in UNTA in 1975?
Give a very brief answer. 9.46e+07. What is the difference between the Aid flow from UN agencies (US$) of UNRWA in 1972 and the Aid flow from UN agencies (US$) of UNAIDS in 1975?
Give a very brief answer. 9.33e+07. What is the difference between the Aid flow from UN agencies (US$) of UNTA in 1972 and the Aid flow from UN agencies (US$) of UNAIDS in 1975?
Ensure brevity in your answer.  -4.62e+06. What is the difference between the Aid flow from UN agencies (US$) of UNHCR in 1973 and the Aid flow from UN agencies (US$) of UNRWA in 1974?
Your answer should be very brief. -1.96e+08. What is the difference between the Aid flow from UN agencies (US$) in UNHCR in 1973 and the Aid flow from UN agencies (US$) in UNTA in 1974?
Offer a very short reply. 6.50e+05. What is the difference between the Aid flow from UN agencies (US$) in UNHCR in 1973 and the Aid flow from UN agencies (US$) in UNAIDS in 1974?
Offer a terse response. 1.16e+06. What is the difference between the Aid flow from UN agencies (US$) in UNRWA in 1973 and the Aid flow from UN agencies (US$) in UNTA in 1974?
Your answer should be very brief. 1.91e+08. What is the difference between the Aid flow from UN agencies (US$) of UNRWA in 1973 and the Aid flow from UN agencies (US$) of UNAIDS in 1974?
Keep it short and to the point. 1.92e+08. What is the difference between the Aid flow from UN agencies (US$) of UNTA in 1973 and the Aid flow from UN agencies (US$) of UNAIDS in 1974?
Keep it short and to the point. -5.70e+05. What is the difference between the Aid flow from UN agencies (US$) in UNHCR in 1973 and the Aid flow from UN agencies (US$) in UNRWA in 1975?
Offer a terse response. -1.27e+08. What is the difference between the Aid flow from UN agencies (US$) in UNHCR in 1973 and the Aid flow from UN agencies (US$) in UNTA in 1975?
Provide a succinct answer. -1.31e+06. What is the difference between the Aid flow from UN agencies (US$) of UNHCR in 1973 and the Aid flow from UN agencies (US$) of UNAIDS in 1975?
Your response must be concise. -2.57e+06. What is the difference between the Aid flow from UN agencies (US$) of UNRWA in 1973 and the Aid flow from UN agencies (US$) of UNTA in 1975?
Offer a terse response. 1.89e+08. What is the difference between the Aid flow from UN agencies (US$) in UNRWA in 1973 and the Aid flow from UN agencies (US$) in UNAIDS in 1975?
Give a very brief answer. 1.88e+08. What is the difference between the Aid flow from UN agencies (US$) of UNTA in 1973 and the Aid flow from UN agencies (US$) of UNAIDS in 1975?
Make the answer very short. -4.30e+06. What is the difference between the Aid flow from UN agencies (US$) in UNHCR in 1974 and the Aid flow from UN agencies (US$) in UNRWA in 1975?
Offer a very short reply. -1.34e+08. What is the difference between the Aid flow from UN agencies (US$) in UNHCR in 1974 and the Aid flow from UN agencies (US$) in UNTA in 1975?
Your response must be concise. -8.38e+06. What is the difference between the Aid flow from UN agencies (US$) of UNHCR in 1974 and the Aid flow from UN agencies (US$) of UNAIDS in 1975?
Keep it short and to the point. -9.64e+06. What is the difference between the Aid flow from UN agencies (US$) of UNRWA in 1974 and the Aid flow from UN agencies (US$) of UNTA in 1975?
Provide a succinct answer. 1.94e+08. What is the difference between the Aid flow from UN agencies (US$) of UNRWA in 1974 and the Aid flow from UN agencies (US$) of UNAIDS in 1975?
Your response must be concise. 1.93e+08. What is the difference between the Aid flow from UN agencies (US$) in UNTA in 1974 and the Aid flow from UN agencies (US$) in UNAIDS in 1975?
Your answer should be very brief. -3.22e+06. What is the average Aid flow from UN agencies (US$) in UNHCR per year?
Ensure brevity in your answer.  5.90e+06. What is the average Aid flow from UN agencies (US$) in UNRWA per year?
Your response must be concise. 9.92e+07. What is the average Aid flow from UN agencies (US$) in UNTA per year?
Provide a succinct answer. 8.38e+06. What is the average Aid flow from UN agencies (US$) in UNAIDS per year?
Your answer should be compact. 9.09e+06. In the year 1969, what is the difference between the Aid flow from UN agencies (US$) of UNHCR and Aid flow from UN agencies (US$) of UNRWA?
Provide a succinct answer. -1.82e+06. In the year 1969, what is the difference between the Aid flow from UN agencies (US$) in UNHCR and Aid flow from UN agencies (US$) in UNTA?
Your response must be concise. -4.07e+06. In the year 1969, what is the difference between the Aid flow from UN agencies (US$) in UNHCR and Aid flow from UN agencies (US$) in UNAIDS?
Provide a succinct answer. -3.47e+06. In the year 1969, what is the difference between the Aid flow from UN agencies (US$) of UNRWA and Aid flow from UN agencies (US$) of UNTA?
Give a very brief answer. -2.25e+06. In the year 1969, what is the difference between the Aid flow from UN agencies (US$) in UNRWA and Aid flow from UN agencies (US$) in UNAIDS?
Keep it short and to the point. -1.65e+06. In the year 1969, what is the difference between the Aid flow from UN agencies (US$) in UNTA and Aid flow from UN agencies (US$) in UNAIDS?
Provide a short and direct response. 6.00e+05. In the year 1970, what is the difference between the Aid flow from UN agencies (US$) in UNHCR and Aid flow from UN agencies (US$) in UNRWA?
Keep it short and to the point. -3.05e+06. In the year 1970, what is the difference between the Aid flow from UN agencies (US$) of UNHCR and Aid flow from UN agencies (US$) of UNTA?
Offer a terse response. -3.85e+06. In the year 1970, what is the difference between the Aid flow from UN agencies (US$) in UNHCR and Aid flow from UN agencies (US$) in UNAIDS?
Offer a terse response. -3.20e+06. In the year 1970, what is the difference between the Aid flow from UN agencies (US$) of UNRWA and Aid flow from UN agencies (US$) of UNTA?
Ensure brevity in your answer.  -8.00e+05. In the year 1970, what is the difference between the Aid flow from UN agencies (US$) in UNRWA and Aid flow from UN agencies (US$) in UNAIDS?
Your answer should be very brief. -1.50e+05. In the year 1970, what is the difference between the Aid flow from UN agencies (US$) of UNTA and Aid flow from UN agencies (US$) of UNAIDS?
Keep it short and to the point. 6.50e+05. In the year 1971, what is the difference between the Aid flow from UN agencies (US$) in UNHCR and Aid flow from UN agencies (US$) in UNRWA?
Offer a terse response. -3.19e+07. In the year 1971, what is the difference between the Aid flow from UN agencies (US$) of UNHCR and Aid flow from UN agencies (US$) of UNTA?
Offer a terse response. -5.55e+06. In the year 1971, what is the difference between the Aid flow from UN agencies (US$) of UNHCR and Aid flow from UN agencies (US$) of UNAIDS?
Offer a terse response. -1.01e+07. In the year 1971, what is the difference between the Aid flow from UN agencies (US$) in UNRWA and Aid flow from UN agencies (US$) in UNTA?
Keep it short and to the point. 2.64e+07. In the year 1971, what is the difference between the Aid flow from UN agencies (US$) in UNRWA and Aid flow from UN agencies (US$) in UNAIDS?
Keep it short and to the point. 2.18e+07. In the year 1971, what is the difference between the Aid flow from UN agencies (US$) in UNTA and Aid flow from UN agencies (US$) in UNAIDS?
Offer a very short reply. -4.55e+06. In the year 1972, what is the difference between the Aid flow from UN agencies (US$) in UNHCR and Aid flow from UN agencies (US$) in UNRWA?
Your response must be concise. -9.04e+07. In the year 1972, what is the difference between the Aid flow from UN agencies (US$) of UNHCR and Aid flow from UN agencies (US$) of UNTA?
Ensure brevity in your answer.  7.53e+06. In the year 1972, what is the difference between the Aid flow from UN agencies (US$) in UNHCR and Aid flow from UN agencies (US$) in UNAIDS?
Give a very brief answer. 7.23e+06. In the year 1972, what is the difference between the Aid flow from UN agencies (US$) of UNRWA and Aid flow from UN agencies (US$) of UNTA?
Give a very brief answer. 9.79e+07. In the year 1972, what is the difference between the Aid flow from UN agencies (US$) of UNRWA and Aid flow from UN agencies (US$) of UNAIDS?
Provide a succinct answer. 9.76e+07. In the year 1972, what is the difference between the Aid flow from UN agencies (US$) of UNTA and Aid flow from UN agencies (US$) of UNAIDS?
Give a very brief answer. -3.00e+05. In the year 1973, what is the difference between the Aid flow from UN agencies (US$) of UNHCR and Aid flow from UN agencies (US$) of UNRWA?
Offer a very short reply. -1.91e+08. In the year 1973, what is the difference between the Aid flow from UN agencies (US$) of UNHCR and Aid flow from UN agencies (US$) of UNTA?
Provide a succinct answer. 1.73e+06. In the year 1973, what is the difference between the Aid flow from UN agencies (US$) of UNHCR and Aid flow from UN agencies (US$) of UNAIDS?
Give a very brief answer. 1.06e+06. In the year 1973, what is the difference between the Aid flow from UN agencies (US$) of UNRWA and Aid flow from UN agencies (US$) of UNTA?
Offer a terse response. 1.92e+08. In the year 1973, what is the difference between the Aid flow from UN agencies (US$) in UNRWA and Aid flow from UN agencies (US$) in UNAIDS?
Your response must be concise. 1.92e+08. In the year 1973, what is the difference between the Aid flow from UN agencies (US$) in UNTA and Aid flow from UN agencies (US$) in UNAIDS?
Your response must be concise. -6.70e+05. In the year 1974, what is the difference between the Aid flow from UN agencies (US$) of UNHCR and Aid flow from UN agencies (US$) of UNRWA?
Offer a terse response. -2.03e+08. In the year 1974, what is the difference between the Aid flow from UN agencies (US$) in UNHCR and Aid flow from UN agencies (US$) in UNTA?
Ensure brevity in your answer.  -6.42e+06. In the year 1974, what is the difference between the Aid flow from UN agencies (US$) of UNHCR and Aid flow from UN agencies (US$) of UNAIDS?
Offer a very short reply. -5.91e+06. In the year 1974, what is the difference between the Aid flow from UN agencies (US$) of UNRWA and Aid flow from UN agencies (US$) of UNTA?
Your answer should be compact. 1.96e+08. In the year 1974, what is the difference between the Aid flow from UN agencies (US$) in UNRWA and Aid flow from UN agencies (US$) in UNAIDS?
Your answer should be compact. 1.97e+08. In the year 1974, what is the difference between the Aid flow from UN agencies (US$) in UNTA and Aid flow from UN agencies (US$) in UNAIDS?
Offer a very short reply. 5.10e+05. In the year 1975, what is the difference between the Aid flow from UN agencies (US$) in UNHCR and Aid flow from UN agencies (US$) in UNRWA?
Give a very brief answer. -1.32e+08. In the year 1975, what is the difference between the Aid flow from UN agencies (US$) of UNHCR and Aid flow from UN agencies (US$) of UNTA?
Your response must be concise. -6.69e+06. In the year 1975, what is the difference between the Aid flow from UN agencies (US$) in UNHCR and Aid flow from UN agencies (US$) in UNAIDS?
Offer a very short reply. -7.95e+06. In the year 1975, what is the difference between the Aid flow from UN agencies (US$) of UNRWA and Aid flow from UN agencies (US$) of UNTA?
Provide a succinct answer. 1.25e+08. In the year 1975, what is the difference between the Aid flow from UN agencies (US$) in UNRWA and Aid flow from UN agencies (US$) in UNAIDS?
Your answer should be compact. 1.24e+08. In the year 1975, what is the difference between the Aid flow from UN agencies (US$) in UNTA and Aid flow from UN agencies (US$) in UNAIDS?
Give a very brief answer. -1.26e+06. What is the ratio of the Aid flow from UN agencies (US$) of UNHCR in 1969 to that in 1970?
Offer a terse response. 1.43. What is the ratio of the Aid flow from UN agencies (US$) in UNRWA in 1969 to that in 1970?
Your response must be concise. 0.9. What is the ratio of the Aid flow from UN agencies (US$) in UNTA in 1969 to that in 1970?
Keep it short and to the point. 1.17. What is the ratio of the Aid flow from UN agencies (US$) in UNAIDS in 1969 to that in 1970?
Your answer should be very brief. 1.2. What is the ratio of the Aid flow from UN agencies (US$) in UNHCR in 1969 to that in 1971?
Your answer should be very brief. 1.22. What is the ratio of the Aid flow from UN agencies (US$) in UNRWA in 1969 to that in 1971?
Ensure brevity in your answer.  0.13. What is the ratio of the Aid flow from UN agencies (US$) in UNTA in 1969 to that in 1971?
Ensure brevity in your answer.  0.86. What is the ratio of the Aid flow from UN agencies (US$) in UNAIDS in 1969 to that in 1971?
Ensure brevity in your answer.  0.49. What is the ratio of the Aid flow from UN agencies (US$) of UNHCR in 1969 to that in 1972?
Offer a very short reply. 0.16. What is the ratio of the Aid flow from UN agencies (US$) in UNRWA in 1969 to that in 1972?
Offer a terse response. 0.04. What is the ratio of the Aid flow from UN agencies (US$) in UNTA in 1969 to that in 1972?
Ensure brevity in your answer.  0.77. What is the ratio of the Aid flow from UN agencies (US$) in UNAIDS in 1969 to that in 1972?
Provide a short and direct response. 0.68. What is the ratio of the Aid flow from UN agencies (US$) in UNHCR in 1969 to that in 1973?
Offer a very short reply. 0.24. What is the ratio of the Aid flow from UN agencies (US$) in UNRWA in 1969 to that in 1973?
Your answer should be compact. 0.02. What is the ratio of the Aid flow from UN agencies (US$) in UNTA in 1969 to that in 1973?
Your answer should be compact. 0.75. What is the ratio of the Aid flow from UN agencies (US$) of UNAIDS in 1969 to that in 1973?
Your answer should be very brief. 0.63. What is the ratio of the Aid flow from UN agencies (US$) of UNHCR in 1969 to that in 1974?
Your response must be concise. 0.72. What is the ratio of the Aid flow from UN agencies (US$) in UNRWA in 1969 to that in 1974?
Make the answer very short. 0.02. What is the ratio of the Aid flow from UN agencies (US$) in UNTA in 1969 to that in 1974?
Your answer should be compact. 0.66. What is the ratio of the Aid flow from UN agencies (US$) of UNAIDS in 1969 to that in 1974?
Offer a very short reply. 0.64. What is the ratio of the Aid flow from UN agencies (US$) in UNHCR in 1969 to that in 1975?
Ensure brevity in your answer.  0.48. What is the ratio of the Aid flow from UN agencies (US$) of UNRWA in 1969 to that in 1975?
Provide a short and direct response. 0.03. What is the ratio of the Aid flow from UN agencies (US$) in UNTA in 1969 to that in 1975?
Provide a short and direct response. 0.55. What is the ratio of the Aid flow from UN agencies (US$) in UNAIDS in 1969 to that in 1975?
Offer a very short reply. 0.45. What is the ratio of the Aid flow from UN agencies (US$) in UNHCR in 1970 to that in 1971?
Provide a succinct answer. 0.86. What is the ratio of the Aid flow from UN agencies (US$) of UNRWA in 1970 to that in 1971?
Offer a very short reply. 0.14. What is the ratio of the Aid flow from UN agencies (US$) of UNTA in 1970 to that in 1971?
Offer a terse response. 0.74. What is the ratio of the Aid flow from UN agencies (US$) in UNAIDS in 1970 to that in 1971?
Offer a very short reply. 0.41. What is the ratio of the Aid flow from UN agencies (US$) in UNHCR in 1970 to that in 1972?
Provide a short and direct response. 0.11. What is the ratio of the Aid flow from UN agencies (US$) of UNRWA in 1970 to that in 1972?
Your answer should be compact. 0.04. What is the ratio of the Aid flow from UN agencies (US$) of UNTA in 1970 to that in 1972?
Your response must be concise. 0.66. What is the ratio of the Aid flow from UN agencies (US$) of UNAIDS in 1970 to that in 1972?
Provide a short and direct response. 0.56. What is the ratio of the Aid flow from UN agencies (US$) in UNHCR in 1970 to that in 1973?
Your answer should be very brief. 0.17. What is the ratio of the Aid flow from UN agencies (US$) of UNRWA in 1970 to that in 1973?
Your answer should be very brief. 0.02. What is the ratio of the Aid flow from UN agencies (US$) of UNTA in 1970 to that in 1973?
Keep it short and to the point. 0.64. What is the ratio of the Aid flow from UN agencies (US$) in UNAIDS in 1970 to that in 1973?
Your answer should be very brief. 0.52. What is the ratio of the Aid flow from UN agencies (US$) in UNHCR in 1970 to that in 1974?
Provide a succinct answer. 0.51. What is the ratio of the Aid flow from UN agencies (US$) in UNRWA in 1970 to that in 1974?
Your answer should be compact. 0.02. What is the ratio of the Aid flow from UN agencies (US$) of UNTA in 1970 to that in 1974?
Provide a succinct answer. 0.57. What is the ratio of the Aid flow from UN agencies (US$) of UNAIDS in 1970 to that in 1974?
Your response must be concise. 0.53. What is the ratio of the Aid flow from UN agencies (US$) in UNHCR in 1970 to that in 1975?
Your answer should be compact. 0.34. What is the ratio of the Aid flow from UN agencies (US$) of UNRWA in 1970 to that in 1975?
Keep it short and to the point. 0.03. What is the ratio of the Aid flow from UN agencies (US$) in UNTA in 1970 to that in 1975?
Give a very brief answer. 0.47. What is the ratio of the Aid flow from UN agencies (US$) of UNAIDS in 1970 to that in 1975?
Provide a succinct answer. 0.38. What is the ratio of the Aid flow from UN agencies (US$) of UNHCR in 1971 to that in 1972?
Your response must be concise. 0.13. What is the ratio of the Aid flow from UN agencies (US$) in UNRWA in 1971 to that in 1972?
Provide a succinct answer. 0.32. What is the ratio of the Aid flow from UN agencies (US$) of UNTA in 1971 to that in 1972?
Ensure brevity in your answer.  0.9. What is the ratio of the Aid flow from UN agencies (US$) of UNAIDS in 1971 to that in 1972?
Provide a short and direct response. 1.38. What is the ratio of the Aid flow from UN agencies (US$) in UNHCR in 1971 to that in 1973?
Your answer should be very brief. 0.19. What is the ratio of the Aid flow from UN agencies (US$) of UNRWA in 1971 to that in 1973?
Your answer should be very brief. 0.17. What is the ratio of the Aid flow from UN agencies (US$) of UNTA in 1971 to that in 1973?
Your response must be concise. 0.86. What is the ratio of the Aid flow from UN agencies (US$) in UNAIDS in 1971 to that in 1973?
Give a very brief answer. 1.28. What is the ratio of the Aid flow from UN agencies (US$) of UNHCR in 1971 to that in 1974?
Give a very brief answer. 0.59. What is the ratio of the Aid flow from UN agencies (US$) of UNRWA in 1971 to that in 1974?
Offer a terse response. 0.16. What is the ratio of the Aid flow from UN agencies (US$) in UNTA in 1971 to that in 1974?
Provide a succinct answer. 0.77. What is the ratio of the Aid flow from UN agencies (US$) in UNAIDS in 1971 to that in 1974?
Your answer should be very brief. 1.3. What is the ratio of the Aid flow from UN agencies (US$) in UNHCR in 1971 to that in 1975?
Provide a succinct answer. 0.4. What is the ratio of the Aid flow from UN agencies (US$) in UNRWA in 1971 to that in 1975?
Give a very brief answer. 0.25. What is the ratio of the Aid flow from UN agencies (US$) of UNTA in 1971 to that in 1975?
Your response must be concise. 0.64. What is the ratio of the Aid flow from UN agencies (US$) of UNAIDS in 1971 to that in 1975?
Your answer should be very brief. 0.93. What is the ratio of the Aid flow from UN agencies (US$) of UNHCR in 1972 to that in 1973?
Give a very brief answer. 1.52. What is the ratio of the Aid flow from UN agencies (US$) of UNRWA in 1972 to that in 1973?
Provide a short and direct response. 0.53. What is the ratio of the Aid flow from UN agencies (US$) in UNTA in 1972 to that in 1973?
Your answer should be compact. 0.96. What is the ratio of the Aid flow from UN agencies (US$) in UNAIDS in 1972 to that in 1973?
Make the answer very short. 0.93. What is the ratio of the Aid flow from UN agencies (US$) in UNHCR in 1972 to that in 1974?
Provide a short and direct response. 4.65. What is the ratio of the Aid flow from UN agencies (US$) in UNRWA in 1972 to that in 1974?
Keep it short and to the point. 0.52. What is the ratio of the Aid flow from UN agencies (US$) in UNTA in 1972 to that in 1974?
Give a very brief answer. 0.86. What is the ratio of the Aid flow from UN agencies (US$) of UNAIDS in 1972 to that in 1974?
Offer a terse response. 0.94. What is the ratio of the Aid flow from UN agencies (US$) of UNHCR in 1972 to that in 1975?
Give a very brief answer. 3.12. What is the ratio of the Aid flow from UN agencies (US$) of UNRWA in 1972 to that in 1975?
Your answer should be very brief. 0.78. What is the ratio of the Aid flow from UN agencies (US$) in UNTA in 1972 to that in 1975?
Your answer should be very brief. 0.72. What is the ratio of the Aid flow from UN agencies (US$) of UNAIDS in 1972 to that in 1975?
Give a very brief answer. 0.67. What is the ratio of the Aid flow from UN agencies (US$) of UNHCR in 1973 to that in 1974?
Provide a succinct answer. 3.06. What is the ratio of the Aid flow from UN agencies (US$) in UNRWA in 1973 to that in 1974?
Your answer should be compact. 0.98. What is the ratio of the Aid flow from UN agencies (US$) of UNTA in 1973 to that in 1974?
Offer a very short reply. 0.89. What is the ratio of the Aid flow from UN agencies (US$) in UNAIDS in 1973 to that in 1974?
Keep it short and to the point. 1.01. What is the ratio of the Aid flow from UN agencies (US$) of UNHCR in 1973 to that in 1975?
Your response must be concise. 2.05. What is the ratio of the Aid flow from UN agencies (US$) in UNRWA in 1973 to that in 1975?
Keep it short and to the point. 1.47. What is the ratio of the Aid flow from UN agencies (US$) in UNTA in 1973 to that in 1975?
Ensure brevity in your answer.  0.74. What is the ratio of the Aid flow from UN agencies (US$) of UNAIDS in 1973 to that in 1975?
Your answer should be very brief. 0.72. What is the ratio of the Aid flow from UN agencies (US$) in UNHCR in 1974 to that in 1975?
Provide a short and direct response. 0.67. What is the ratio of the Aid flow from UN agencies (US$) of UNRWA in 1974 to that in 1975?
Provide a short and direct response. 1.5. What is the ratio of the Aid flow from UN agencies (US$) of UNTA in 1974 to that in 1975?
Give a very brief answer. 0.83. What is the ratio of the Aid flow from UN agencies (US$) in UNAIDS in 1974 to that in 1975?
Keep it short and to the point. 0.71. What is the difference between the highest and the second highest Aid flow from UN agencies (US$) of UNHCR?
Your response must be concise. 5.48e+06. What is the difference between the highest and the second highest Aid flow from UN agencies (US$) of UNRWA?
Give a very brief answer. 5.11e+06. What is the difference between the highest and the second highest Aid flow from UN agencies (US$) in UNTA?
Offer a terse response. 1.96e+06. What is the difference between the highest and the second highest Aid flow from UN agencies (US$) in UNAIDS?
Keep it short and to the point. 9.50e+05. What is the difference between the highest and the lowest Aid flow from UN agencies (US$) in UNHCR?
Offer a very short reply. 1.42e+07. What is the difference between the highest and the lowest Aid flow from UN agencies (US$) in UNRWA?
Ensure brevity in your answer.  2.02e+08. What is the difference between the highest and the lowest Aid flow from UN agencies (US$) in UNTA?
Provide a short and direct response. 6.23e+06. What is the difference between the highest and the lowest Aid flow from UN agencies (US$) in UNAIDS?
Offer a terse response. 8.14e+06. 